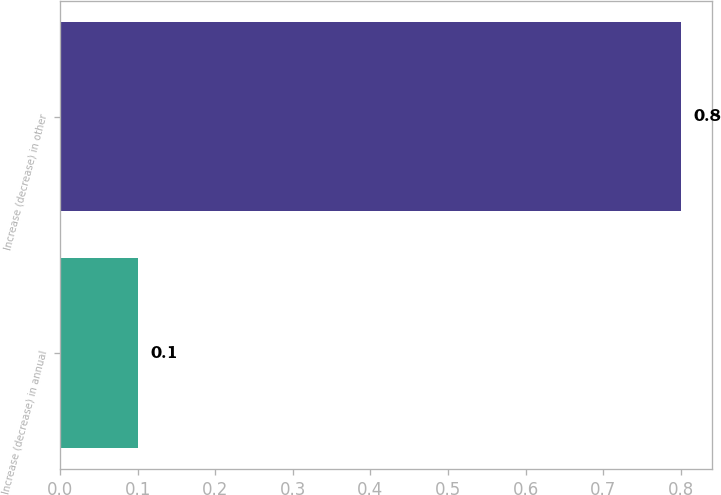Convert chart. <chart><loc_0><loc_0><loc_500><loc_500><bar_chart><fcel>Increase (decrease) in annual<fcel>Increase (decrease) in other<nl><fcel>0.1<fcel>0.8<nl></chart> 